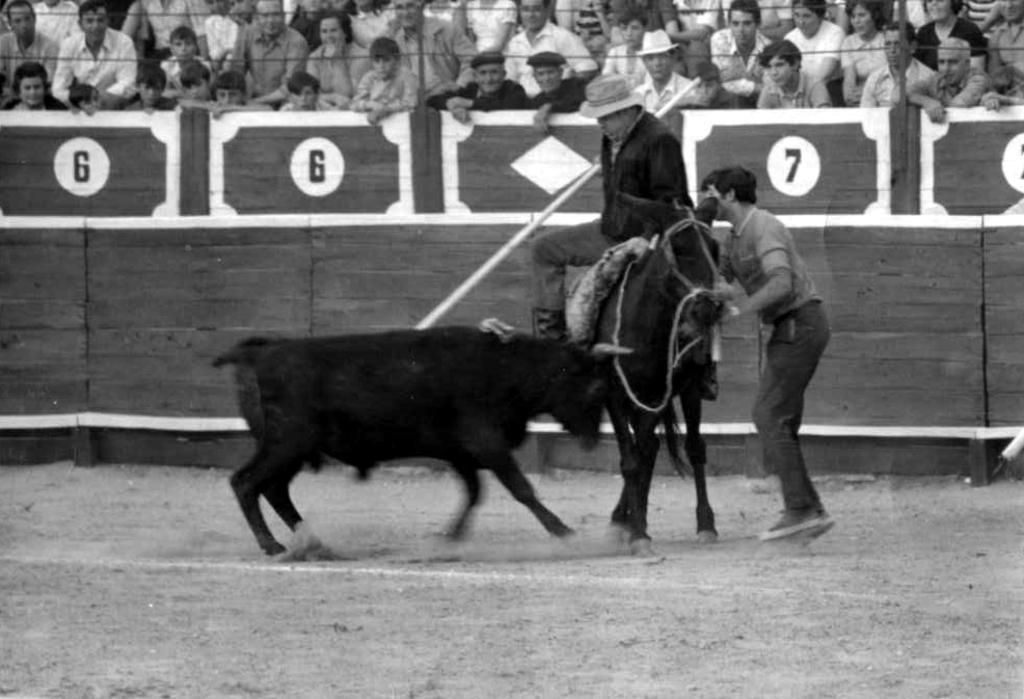How would you summarize this image in a sentence or two? This is a black and white picture. Here we can see a man on the horse. He wear a hat. On the background we can see some persons. Here we can see a man who is standing on the ground. 